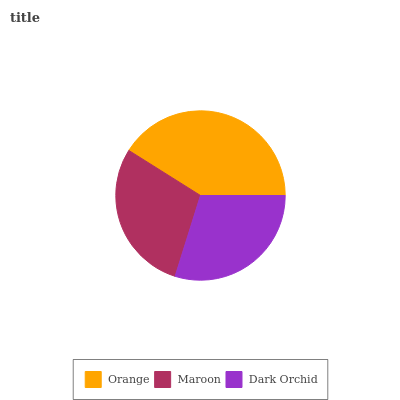Is Maroon the minimum?
Answer yes or no. Yes. Is Orange the maximum?
Answer yes or no. Yes. Is Dark Orchid the minimum?
Answer yes or no. No. Is Dark Orchid the maximum?
Answer yes or no. No. Is Dark Orchid greater than Maroon?
Answer yes or no. Yes. Is Maroon less than Dark Orchid?
Answer yes or no. Yes. Is Maroon greater than Dark Orchid?
Answer yes or no. No. Is Dark Orchid less than Maroon?
Answer yes or no. No. Is Dark Orchid the high median?
Answer yes or no. Yes. Is Dark Orchid the low median?
Answer yes or no. Yes. Is Orange the high median?
Answer yes or no. No. Is Orange the low median?
Answer yes or no. No. 